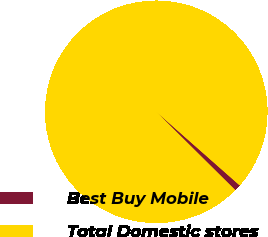Convert chart to OTSL. <chart><loc_0><loc_0><loc_500><loc_500><pie_chart><fcel>Best Buy Mobile<fcel>Total Domestic stores<nl><fcel>0.92%<fcel>99.08%<nl></chart> 